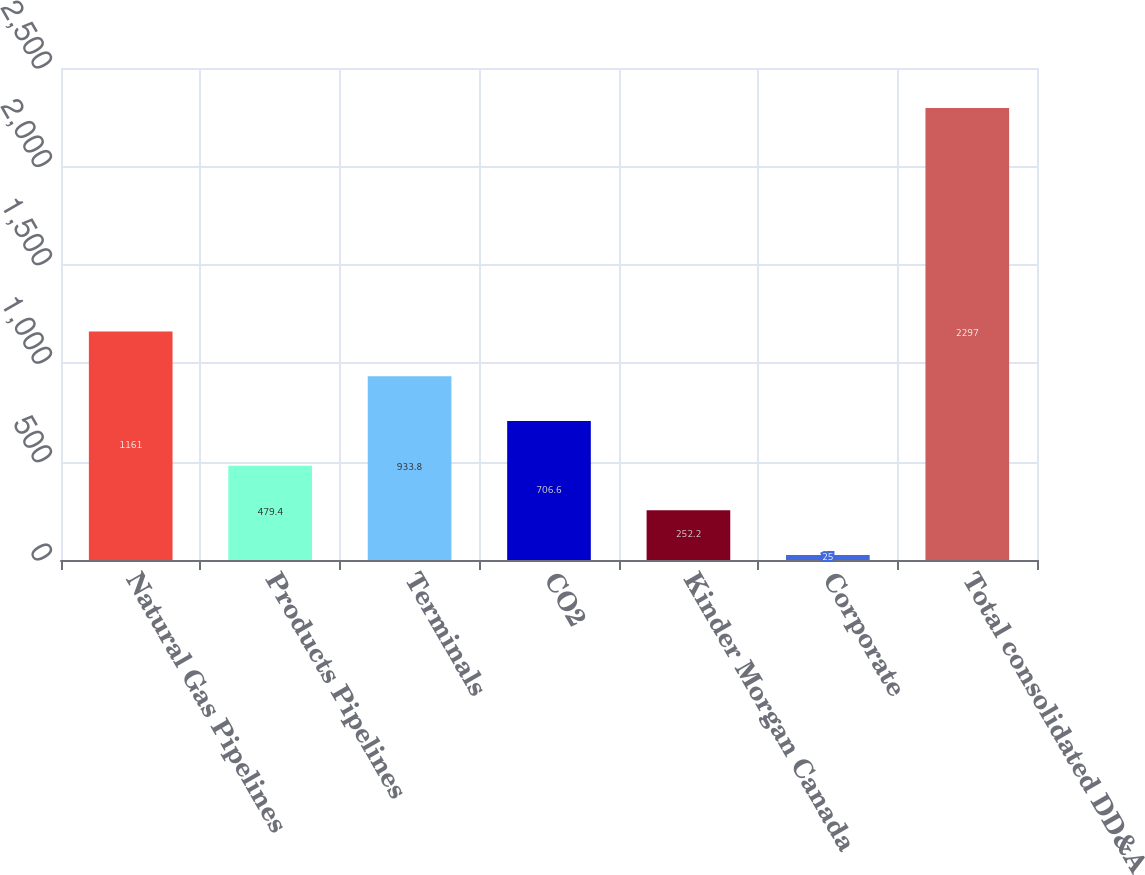Convert chart to OTSL. <chart><loc_0><loc_0><loc_500><loc_500><bar_chart><fcel>Natural Gas Pipelines<fcel>Products Pipelines<fcel>Terminals<fcel>CO2<fcel>Kinder Morgan Canada<fcel>Corporate<fcel>Total consolidated DD&A<nl><fcel>1161<fcel>479.4<fcel>933.8<fcel>706.6<fcel>252.2<fcel>25<fcel>2297<nl></chart> 